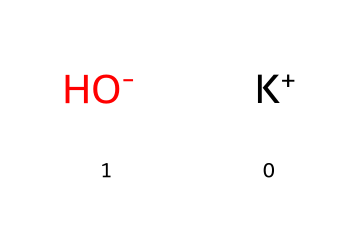What is the main component of this chemical? The chemical consists of potassium ions (K+) and hydroxide ions (OH-), with the hydroxide ion being a key component that classifies it as a base.
Answer: potassium hydroxide How many atoms are present in potassium hydroxide? The chemical has a total of three atoms: one potassium (K) atom and two oxygen (from the OH group, which includes one oxygen atom and one hydrogen atom).
Answer: three What type of ions are present in this chemical? The chemical contains a cation (K+) and an anion (OH-), which are characteristic of bases since they frequently contain hydroxide ions.
Answer: cation and anion What is the pH nature of potassium hydroxide? Potassium hydroxide is a strong base that dissociates completely in solution, resulting in a high pH level typically above 12.
Answer: high How does potassium hydroxide interact with acids? It reacts with acids to form salt and water in a neutralization reaction, which is a typical characteristic of bases.
Answer: forms salt and water What role does hydroxide play in potassium hydroxide? The hydroxide ion (OH-) is responsible for the basic property of the chemical, allowing it to accept protons (H+).
Answer: basic property 